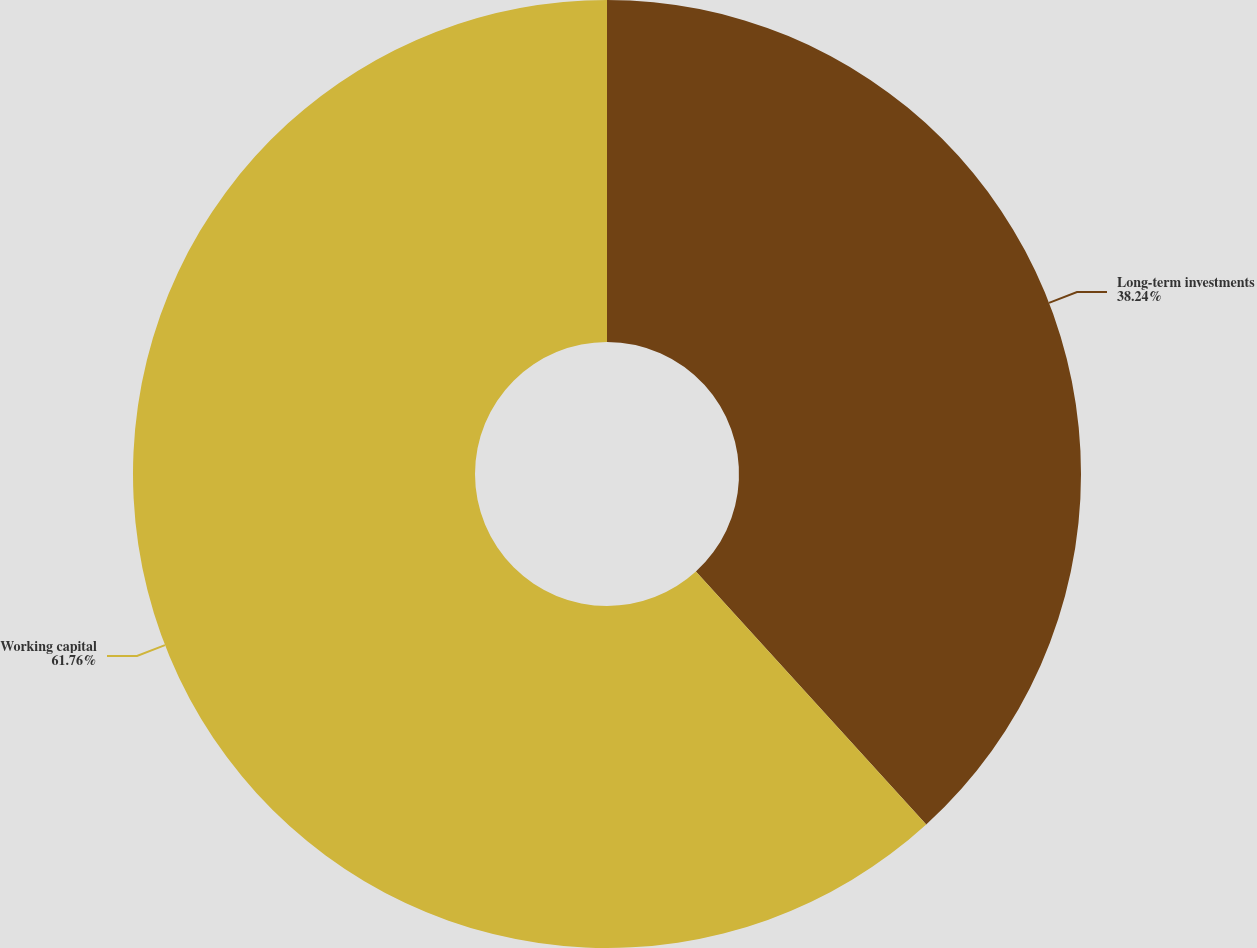Convert chart. <chart><loc_0><loc_0><loc_500><loc_500><pie_chart><fcel>Long-term investments<fcel>Working capital<nl><fcel>38.24%<fcel>61.76%<nl></chart> 